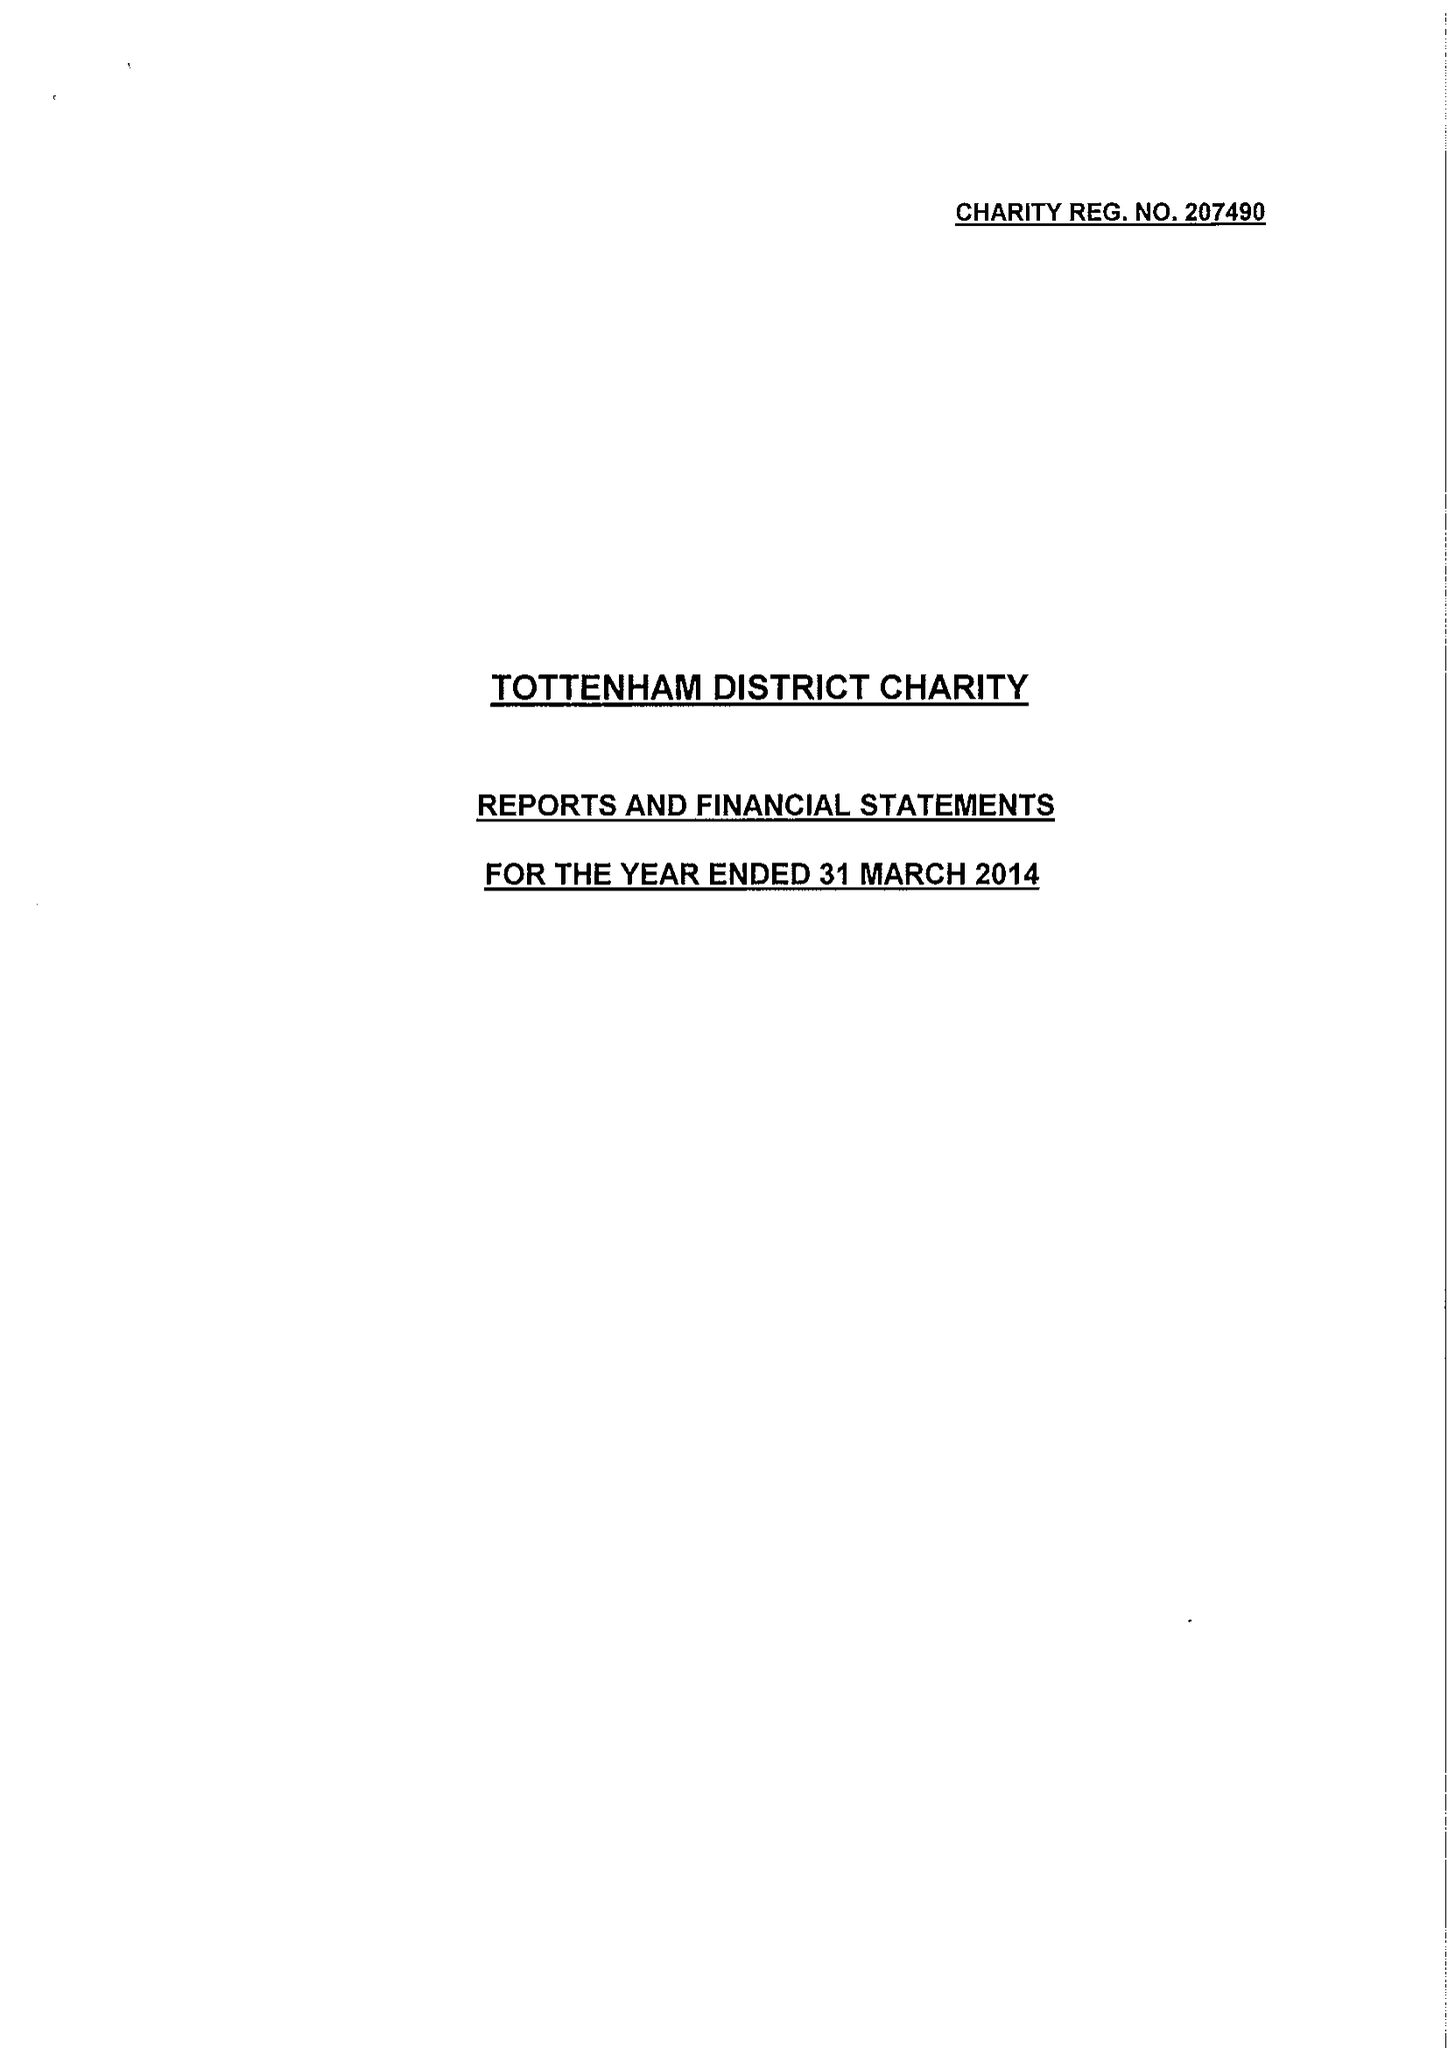What is the value for the charity_name?
Answer the question using a single word or phrase. Tottenham District Charity 